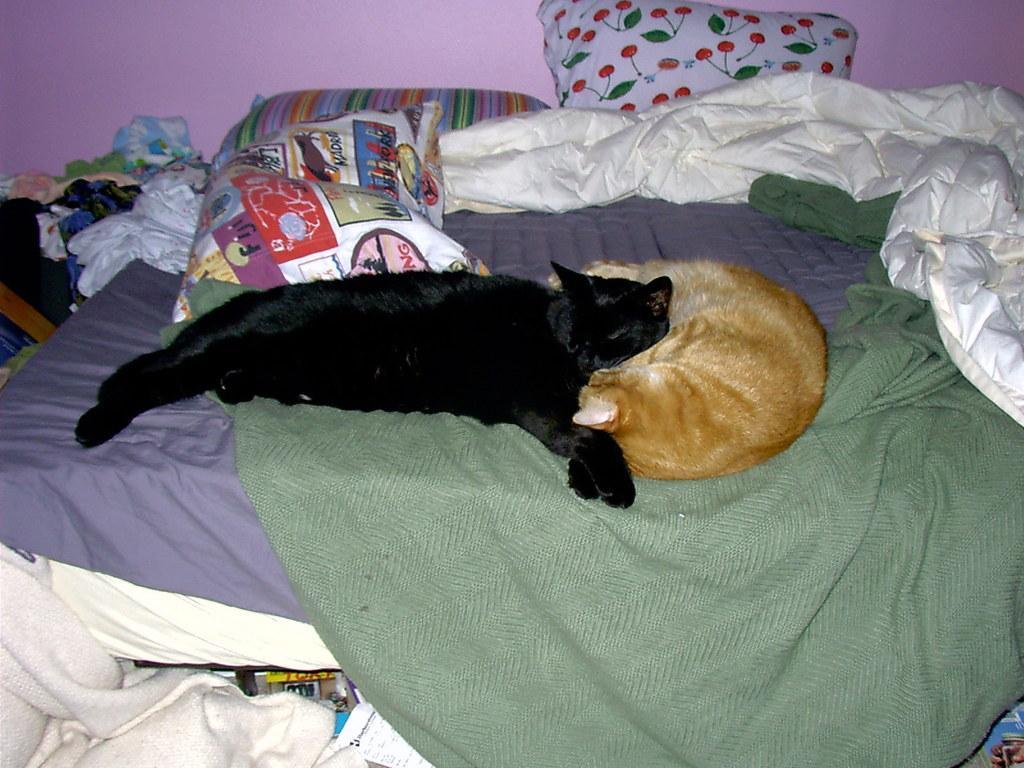Could you give a brief overview of what you see in this image? A black and a brown cat is lying on the bed. On the bed there are bed sheets, blankets, pillows, dresses, towel. And the wall is pink in color. 